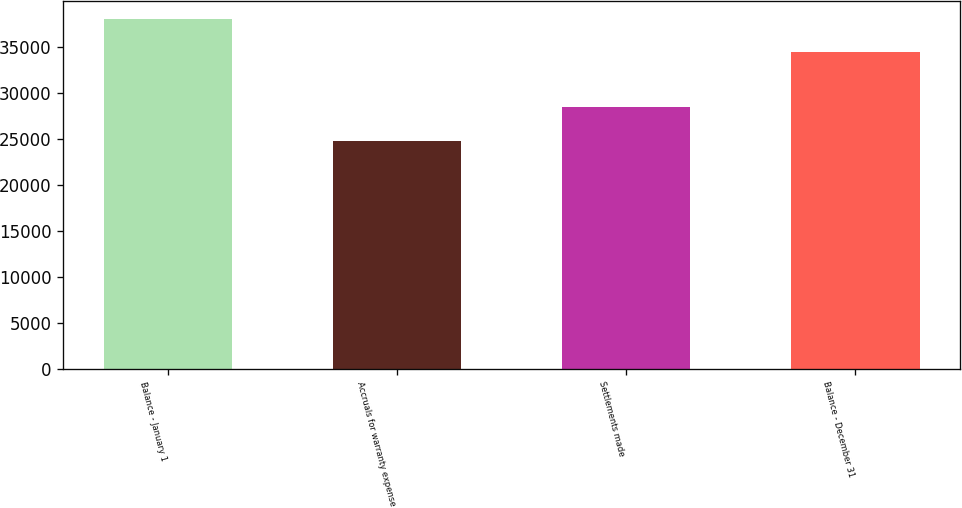Convert chart. <chart><loc_0><loc_0><loc_500><loc_500><bar_chart><fcel>Balance - January 1<fcel>Accruals for warranty expense<fcel>Settlements made<fcel>Balance - December 31<nl><fcel>38024<fcel>24779<fcel>28429<fcel>34374<nl></chart> 